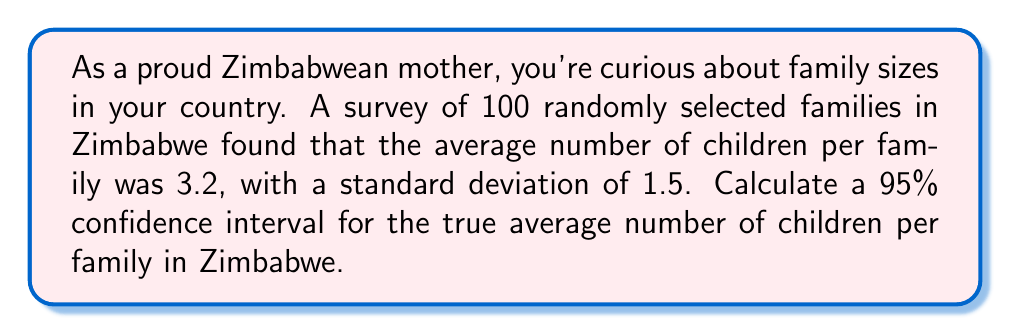Solve this math problem. Let's approach this step-by-step:

1. Identify the given information:
   - Sample size: $n = 100$
   - Sample mean: $\bar{x} = 3.2$
   - Sample standard deviation: $s = 1.5$
   - Confidence level: 95%

2. For a 95% confidence interval, we use a z-score of 1.96.

3. The formula for the confidence interval is:

   $$\bar{x} \pm z \cdot \frac{s}{\sqrt{n}}$$

4. Calculate the margin of error:
   $$\text{Margin of Error} = z \cdot \frac{s}{\sqrt{n}} = 1.96 \cdot \frac{1.5}{\sqrt{100}} = 1.96 \cdot 0.15 = 0.294$$

5. Calculate the lower and upper bounds of the confidence interval:
   - Lower bound: $3.2 - 0.294 = 2.906$
   - Upper bound: $3.2 + 0.294 = 3.494$

6. Round the results to two decimal places for practical interpretation.
Answer: (2.91, 3.49) 